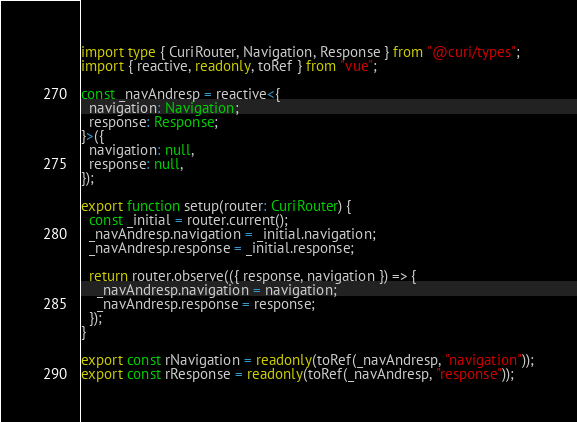<code> <loc_0><loc_0><loc_500><loc_500><_TypeScript_>import type { CuriRouter, Navigation, Response } from "@curi/types";
import { reactive, readonly, toRef } from "vue";

const _navAndresp = reactive<{
  navigation: Navigation;
  response: Response;
}>({
  navigation: null,
  response: null,
});

export function setup(router: CuriRouter) {
  const _initial = router.current();
  _navAndresp.navigation = _initial.navigation;
  _navAndresp.response = _initial.response;

  return router.observe(({ response, navigation }) => {
    _navAndresp.navigation = navigation;
    _navAndresp.response = response;
  });
}

export const rNavigation = readonly(toRef(_navAndresp, "navigation"));
export const rResponse = readonly(toRef(_navAndresp, "response"));
</code> 